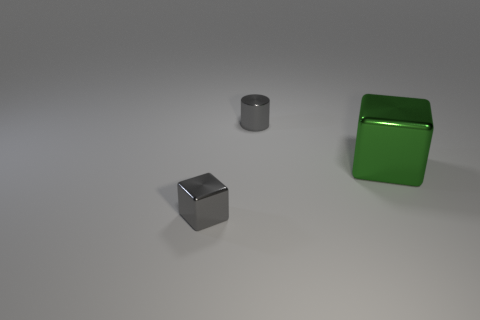Is the color of the tiny shiny cylinder the same as the tiny metal block?
Provide a succinct answer. Yes. How many cubes are either small matte objects or big things?
Your response must be concise. 1. What shape is the small gray object that is in front of the object behind the big green metallic cube?
Make the answer very short. Cube. There is a object in front of the green block; does it have the same size as the gray cylinder?
Ensure brevity in your answer.  Yes. What number of other things are there of the same material as the large green thing
Your answer should be very brief. 2. What number of gray objects are either large shiny blocks or tiny shiny objects?
Offer a very short reply. 2. What is the size of the cylinder that is the same color as the small metallic block?
Your answer should be compact. Small. How many small metal cubes are in front of the small gray block?
Make the answer very short. 0. There is a gray object that is on the left side of the small gray object right of the small shiny object that is left of the gray metallic cylinder; what size is it?
Provide a short and direct response. Small. Is there a small thing in front of the tiny thing right of the gray object that is in front of the small gray shiny cylinder?
Ensure brevity in your answer.  Yes. 